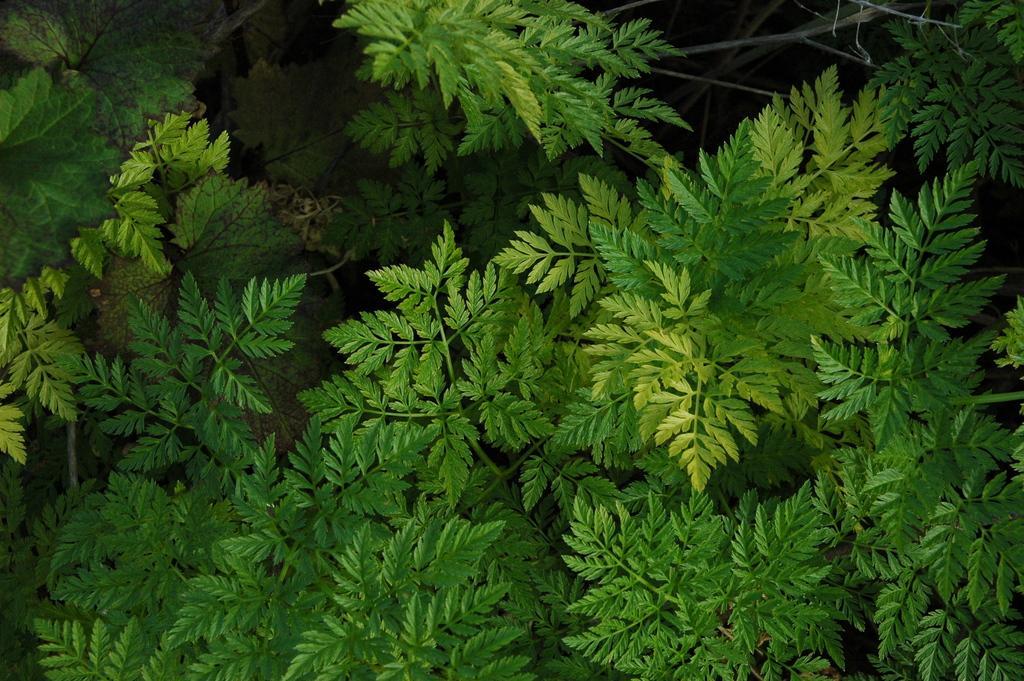How would you summarize this image in a sentence or two? In this picture we observe several green leaf plants. 